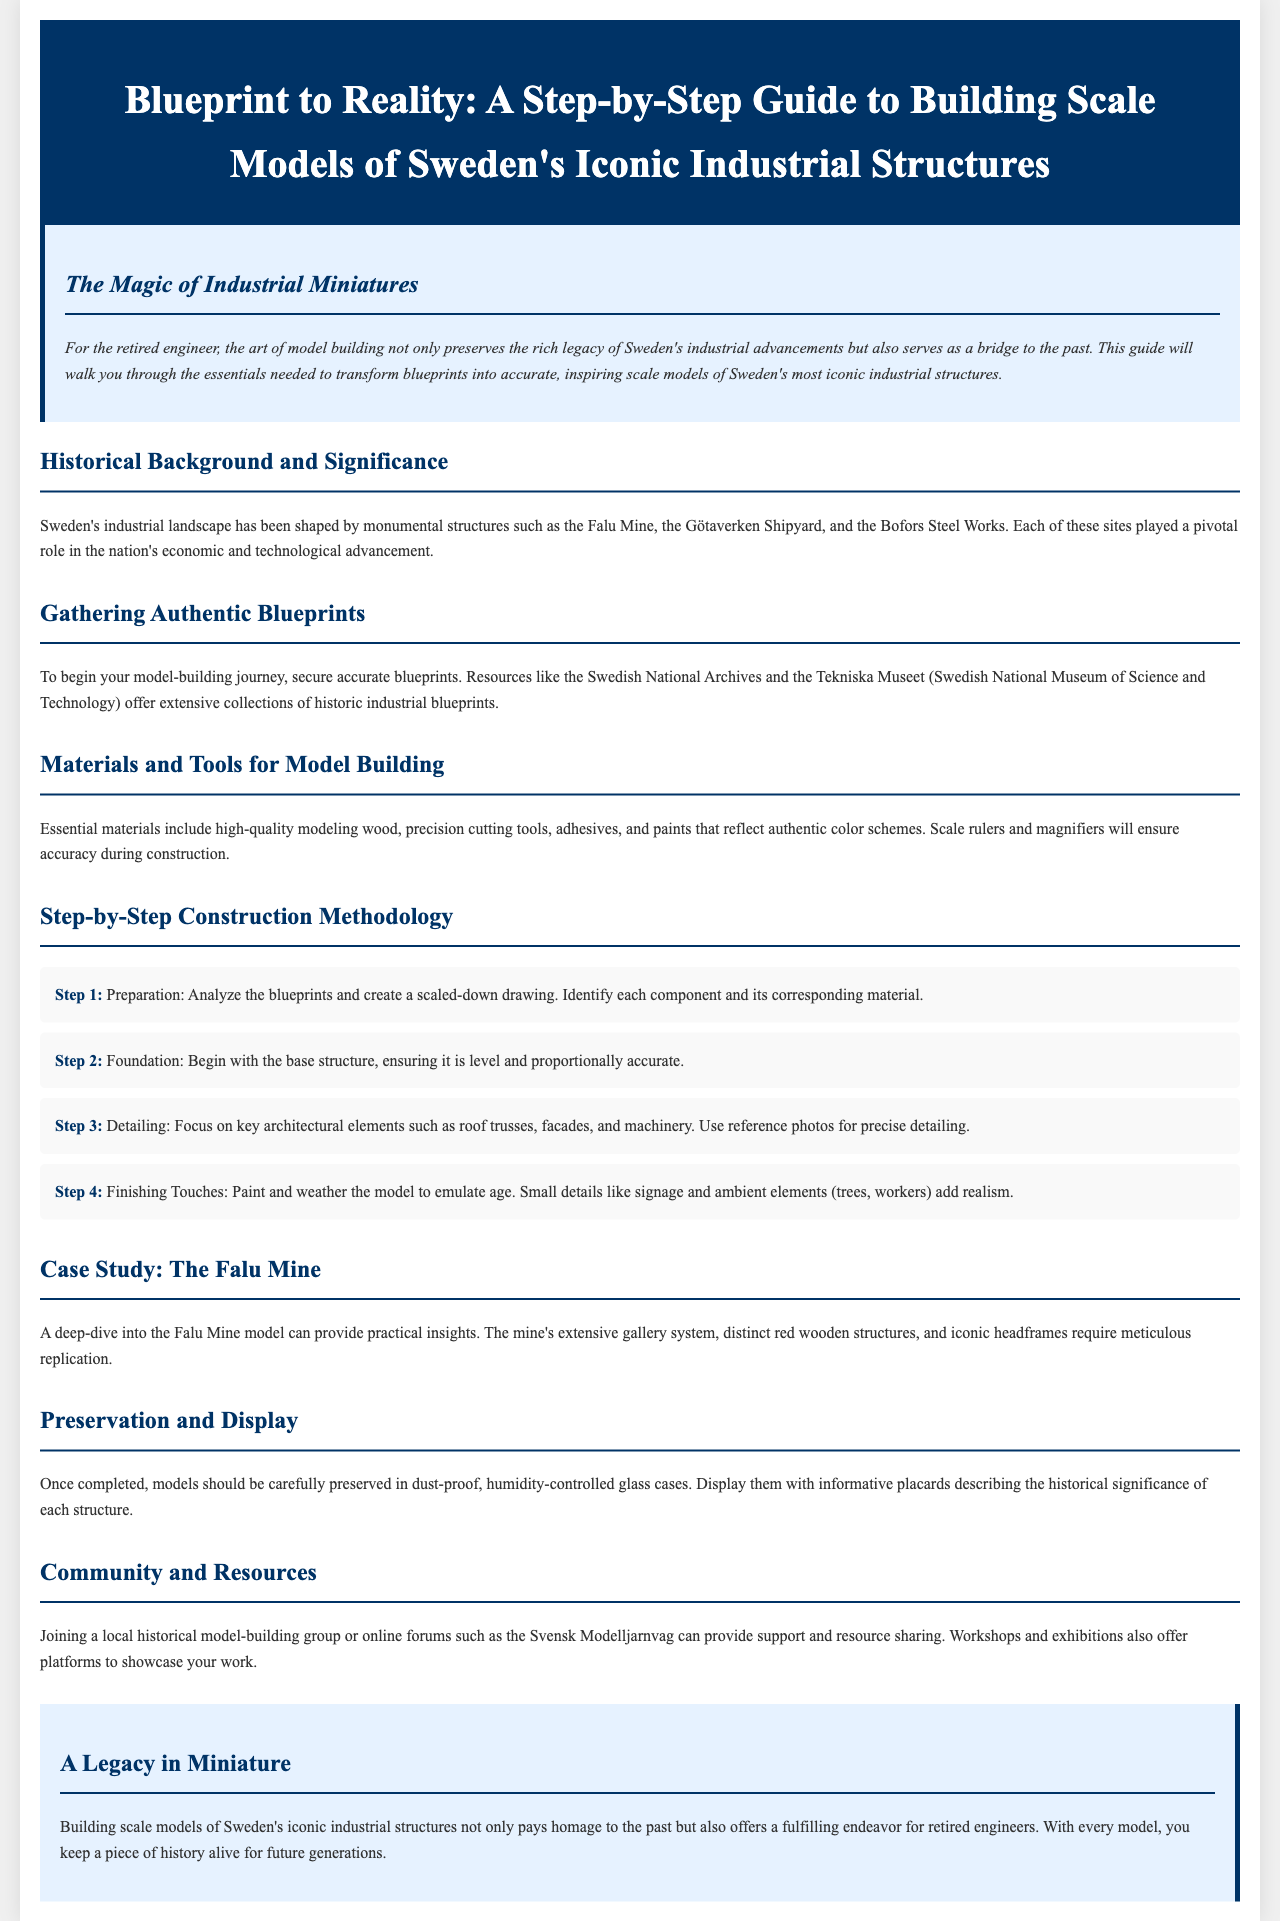What is the title of the document? The title is explicitly stated at the beginning of the document, indicating the main focus of the whitepaper.
Answer: Blueprint to Reality: A Step-by-Step Guide to Building Scale Models of Sweden's Iconic Industrial Structures What structures are highlighted in the historical background? The historical background mentions specific sites influential to Sweden's industrial advancement.
Answer: Falu Mine, Götaverken Shipyard, Bofors Steel Works Where can authentic blueprints be gathered? The document references specific institutions that provide access to historical blueprints for model building.
Answer: Swedish National Archives, Tekniska Museet How many steps are outlined in the construction methodology? The construction methodology section lists a specific number of steps necessary for creating scale models.
Answer: Four What is the color of the Falu Mine's structures? The case study section describes the distinct color associated with the structures of the Falu Mine.
Answer: Red What should models be preserved in? The preservation section specifies a type of display case suitable for the completed models.
Answer: Dust-proof, humidity-controlled glass cases What community resources are mentioned for model builders? The document suggests types of groups that retired engineers can join for support and sharing resources.
Answer: Local historical model-building group, online forums What is one key detail that adds realism to the models? The finishing touches section describes an important element that enhances the authenticity of the models.
Answer: Signage 